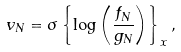Convert formula to latex. <formula><loc_0><loc_0><loc_500><loc_500>v _ { N } = \sigma \left \{ \log \left ( \frac { f _ { N } } { g _ { N } } \right ) \right \} _ { x } ,</formula> 